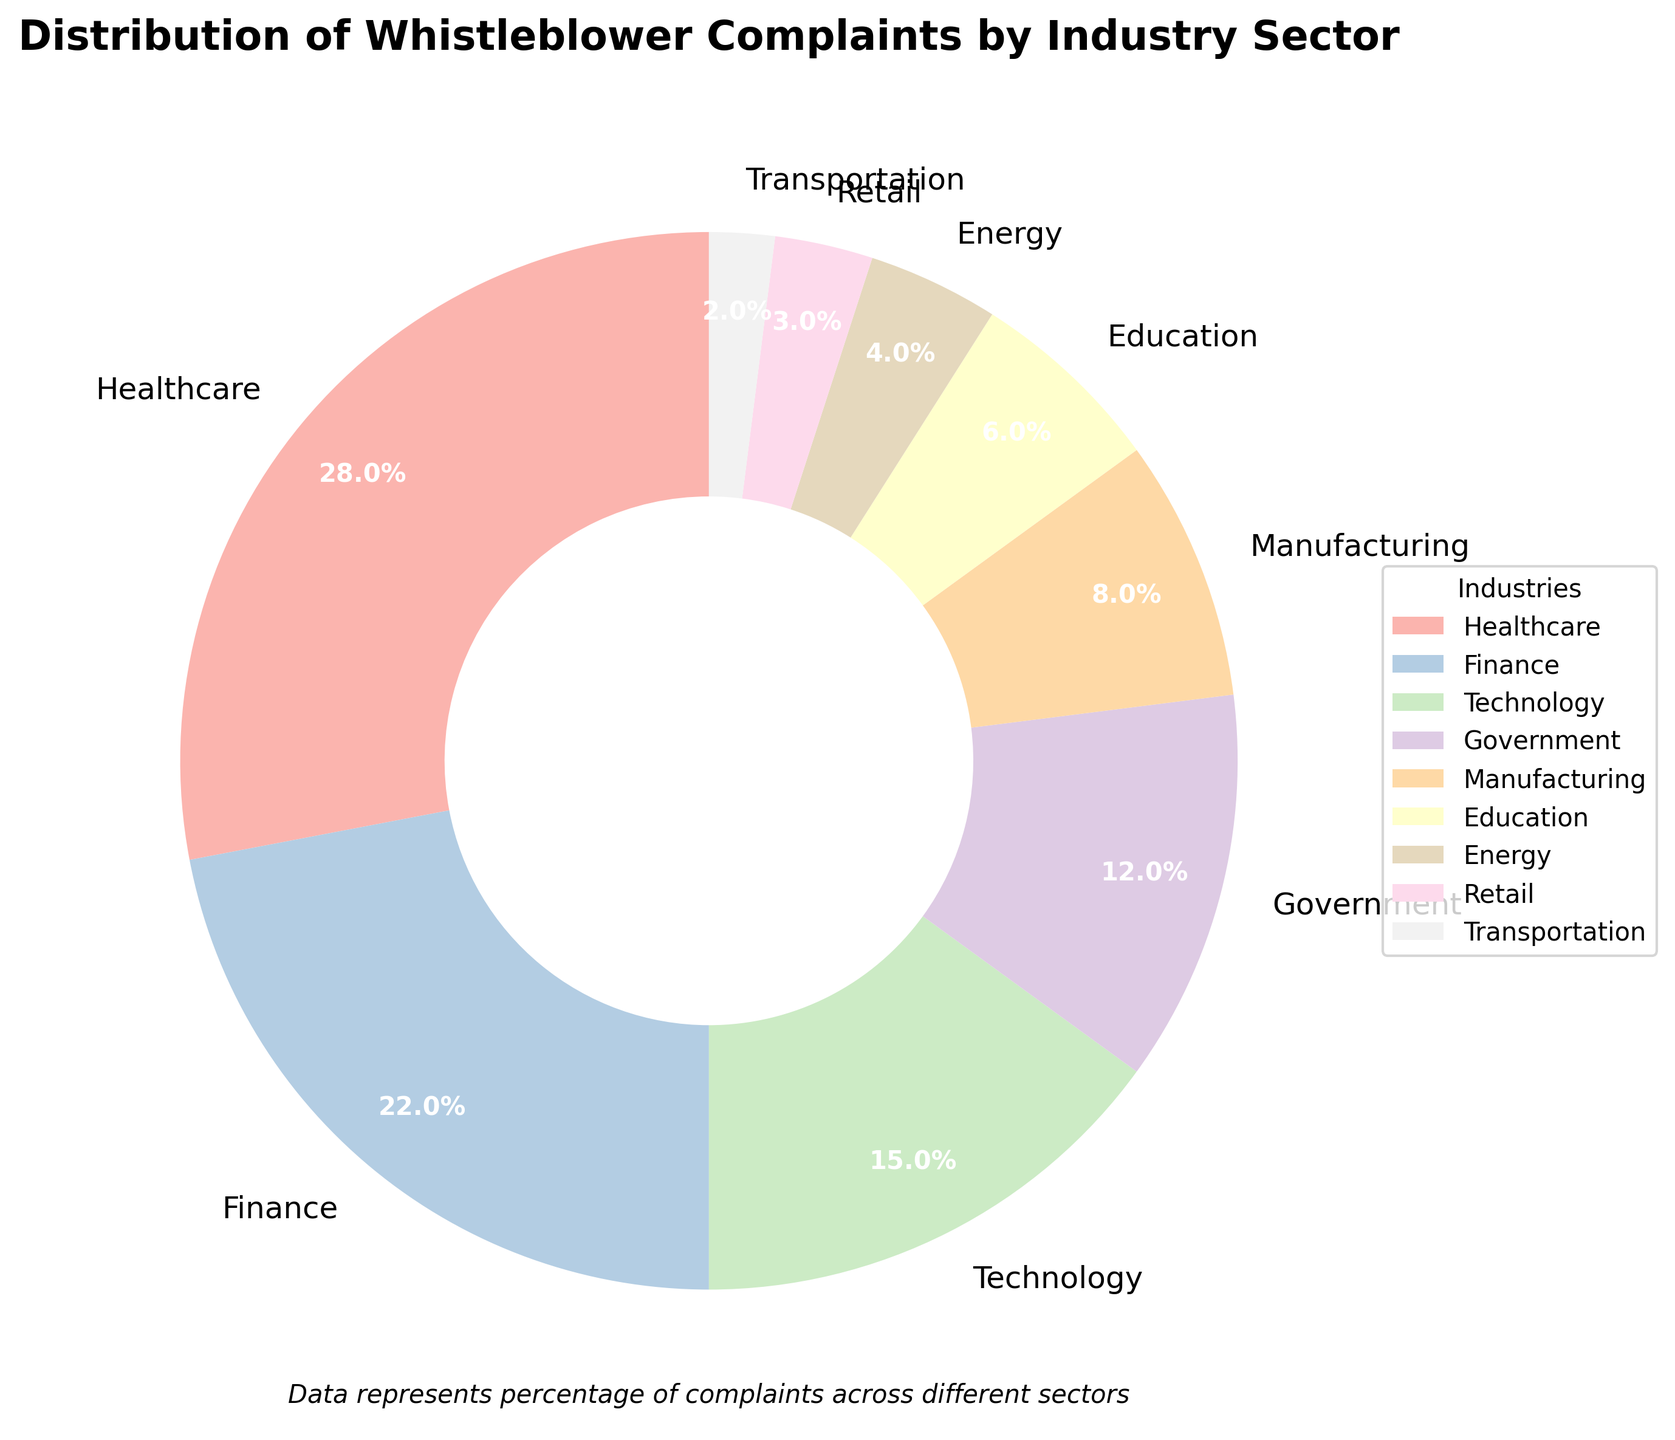Which industry sector has the highest percentage of whistleblower complaints? To find the industry sector with the highest percentage, look for the largest slice of the pie chart and read the label. The largest slice is labeled as "Healthcare", which accounts for 28% of the complaints.
Answer: Healthcare Which two industry sectors combined account for exactly 20% of whistleblower complaints? To determine this, look at sectors with percentages that add up to 20%. The sectors "Retail" (3%) and "Transportation" (2%) combined with any other sectors do not add up to 20%. "Energy" (4%) and "Education" (6%) combined alone also do not work. But "Manufacturing" (8%) and "Energy" (4%) combined with "Transportation" (2%) and another sector does make sense: "Technology" (15%) and "Government" (12%) combined (6% =18 - 15 - 3%)
Answer: There are no two sectors that add up to 20% How much more percentage does the Finance sector have compared to the Technology sector? To find the difference in percentages between the Finance and Technology sectors, subtract the Technology percentage from the Finance percentage. Finance is 22% and Technology is 15%, so 22 - 15 = 7.
Answer: 7% Which industry sector has a smaller percentage of whistleblower complaints, Retail or Energy? To find which sector has a smaller percentage, compare the percentages for Retail and Energy. Retail is 3% and Energy is 4%, so Retail has a smaller percentage.
Answer: Retail What is the combined percentage of whistleblower complaints for the Healthcare and Government sectors? To find the combined percentage for Healthcare and Government sectors, add the percentage values. Healthcare is 28% and Government is 12%, so 28 + 12 = 40.
Answer: 40% Is the percentage of whistleblower complaints in the Education sector greater than in the Manufacturing sector? To determine if the Education sector has a greater percentage than the Manufacturing sector, compare the percentage values. Education is 6% and Manufacturing is 8%, so Education is not greater than Manufacturing.
Answer: No Which sector represents the lowest percentage of whistleblower complaints and what is that percentage? To find the sector with the lowest percentage, look for the smallest slice of the pie chart and read the label. The smallest slice is labeled "Transportation", which accounts for 2%.
Answer: Transportation, 2% What percentage of whistleblower complaints come from the Finance, Technology, and Government sectors combined? To find the combined percentage for Finance, Technology, and Government sectors, add the percentage values. Finance is 22%, Technology is 15%, and Government is 12%, so 22 + 15 + 12 = 49.
Answer: 49% How does the percentage of whistleblower complaints in the Manufacturing sector compare to the percentage in the Education sector? To compare the percentages, look at the values for Manufacturing and Education. Manufacturing is 8% and Education is 6%, so Manufacturing has a higher percentage than Education by a difference of 8 - 6 = 2.
Answer: Manufacturing has 2% more What is the second largest industry sector in terms of whistleblower complaints and its percentage? To find the second largest sector, look for the second largest slice of the pie chart. The largest is Healthcare with 28%, and the next largest is Finance at 22%.
Answer: Finance, 22% 